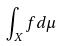<formula> <loc_0><loc_0><loc_500><loc_500>\int _ { X } f d \mu</formula> 